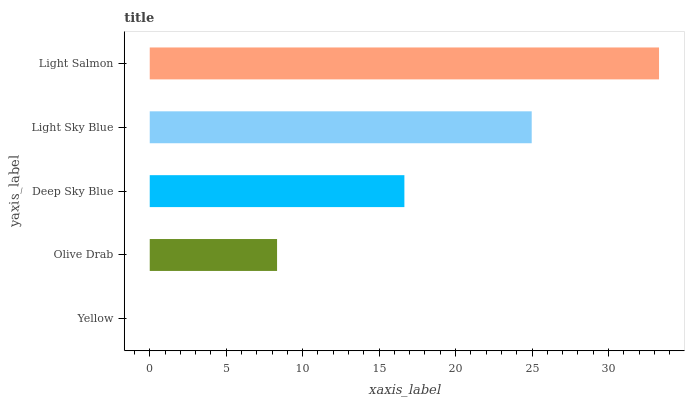Is Yellow the minimum?
Answer yes or no. Yes. Is Light Salmon the maximum?
Answer yes or no. Yes. Is Olive Drab the minimum?
Answer yes or no. No. Is Olive Drab the maximum?
Answer yes or no. No. Is Olive Drab greater than Yellow?
Answer yes or no. Yes. Is Yellow less than Olive Drab?
Answer yes or no. Yes. Is Yellow greater than Olive Drab?
Answer yes or no. No. Is Olive Drab less than Yellow?
Answer yes or no. No. Is Deep Sky Blue the high median?
Answer yes or no. Yes. Is Deep Sky Blue the low median?
Answer yes or no. Yes. Is Light Salmon the high median?
Answer yes or no. No. Is Yellow the low median?
Answer yes or no. No. 